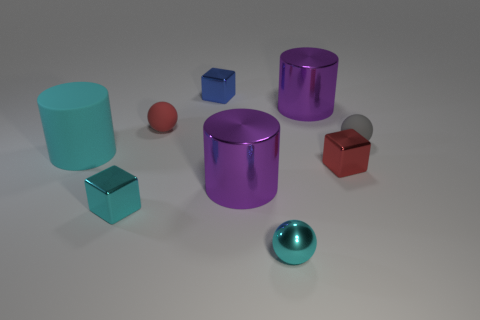Do the rubber object that is to the right of the blue cube and the cyan matte cylinder have the same size?
Offer a very short reply. No. How many big shiny objects are there?
Offer a very short reply. 2. What number of small balls are both in front of the cyan matte thing and on the right side of the small red shiny block?
Provide a short and direct response. 0. Are there any balls that have the same material as the blue object?
Offer a very short reply. Yes. There is a purple object that is left of the shiny cylinder behind the big cyan cylinder; what is its material?
Your answer should be compact. Metal. Is the number of metal objects to the left of the red block the same as the number of small metal things on the right side of the small red sphere?
Your answer should be compact. No. Does the gray object have the same shape as the red matte object?
Your answer should be compact. Yes. What is the sphere that is both in front of the red rubber sphere and to the left of the gray rubber ball made of?
Your response must be concise. Metal. How many small purple metallic things are the same shape as the tiny red shiny thing?
Ensure brevity in your answer.  0. There is a matte ball to the right of the big metal thing that is on the left side of the big metal cylinder behind the gray ball; how big is it?
Offer a terse response. Small. 